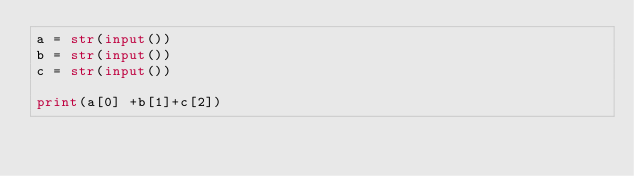<code> <loc_0><loc_0><loc_500><loc_500><_Python_>a = str(input())
b = str(input())
c = str(input())

print(a[0] +b[1]+c[2])</code> 